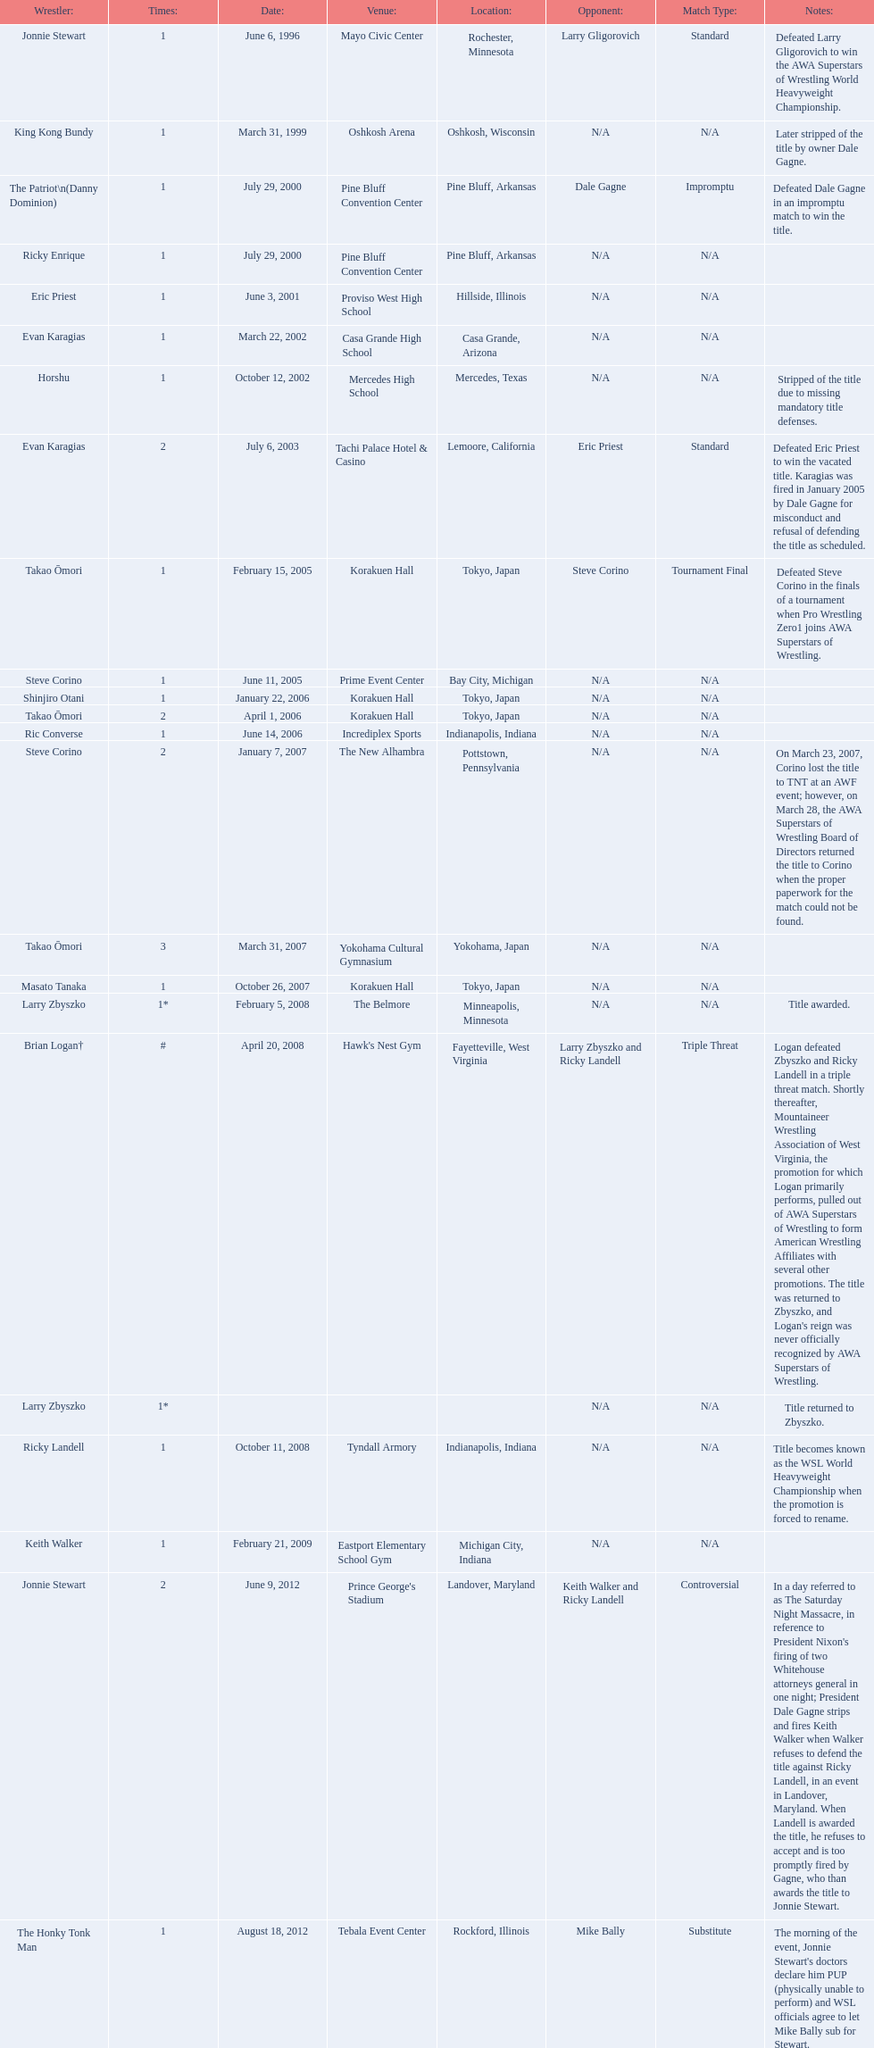Where are the title holders from? Rochester, Minnesota, Oshkosh, Wisconsin, Pine Bluff, Arkansas, Pine Bluff, Arkansas, Hillside, Illinois, Casa Grande, Arizona, Mercedes, Texas, Lemoore, California, Tokyo, Japan, Bay City, Michigan, Tokyo, Japan, Tokyo, Japan, Indianapolis, Indiana, Pottstown, Pennsylvania, Yokohama, Japan, Tokyo, Japan, Minneapolis, Minnesota, Fayetteville, West Virginia, , Indianapolis, Indiana, Michigan City, Indiana, Landover, Maryland, Rockford, Illinois. Who is the title holder from texas? Horshu. 